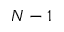<formula> <loc_0><loc_0><loc_500><loc_500>N - 1</formula> 